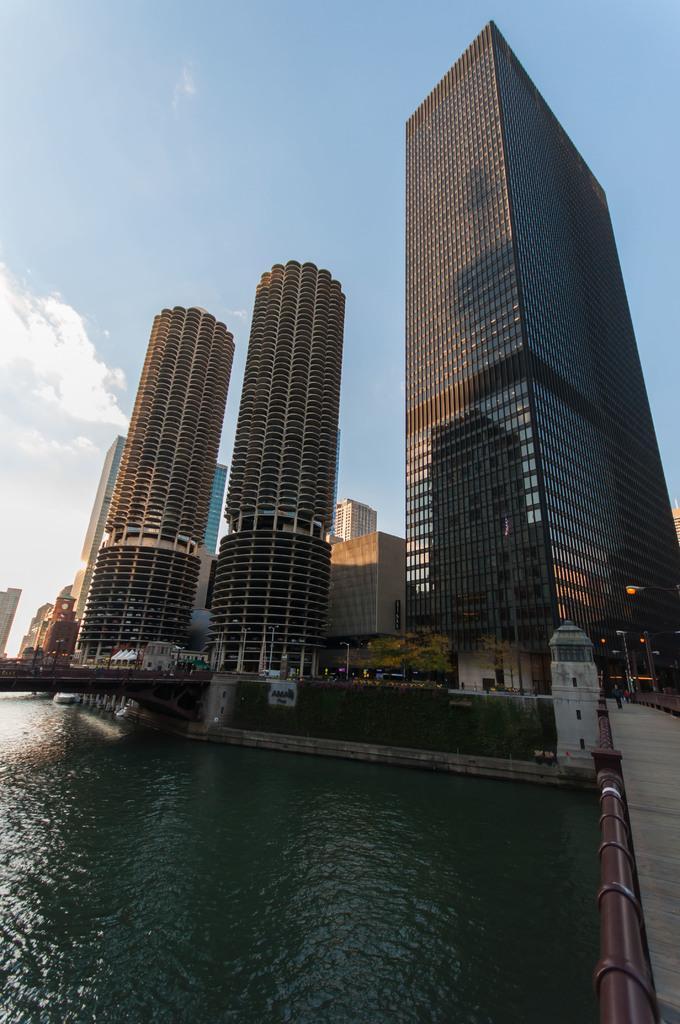How would you summarize this image in a sentence or two? In this image we can see some buildings, poles, bridge and other objects. In the background of the image there is the sky. At the bottom of the image there is water. On the right side of the image there is a road and an iron object. 